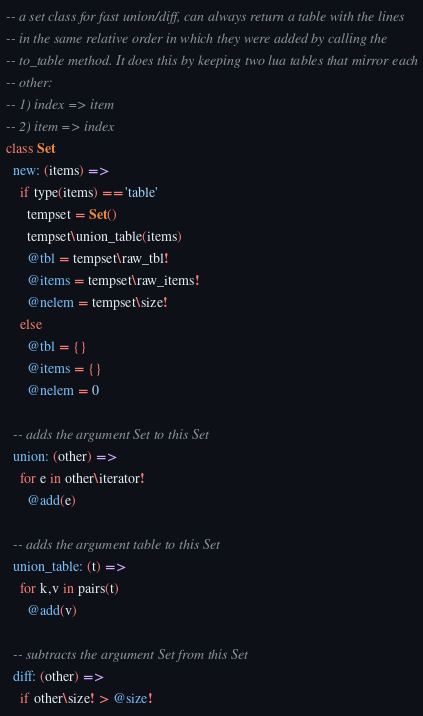Convert code to text. <code><loc_0><loc_0><loc_500><loc_500><_MoonScript_>-- a set class for fast union/diff, can always return a table with the lines
-- in the same relative order in which they were added by calling the
-- to_table method. It does this by keeping two lua tables that mirror each
-- other:
-- 1) index => item
-- 2) item => index
class Set
  new: (items) =>
    if type(items) == 'table'
      tempset = Set()
      tempset\union_table(items)
      @tbl = tempset\raw_tbl!
      @items = tempset\raw_items!
      @nelem = tempset\size!
    else
      @tbl = {}
      @items = {}
      @nelem = 0

  -- adds the argument Set to this Set
  union: (other) =>
    for e in other\iterator!
      @add(e)

  -- adds the argument table to this Set
  union_table: (t) =>
    for k,v in pairs(t)
      @add(v)

  -- subtracts the argument Set from this Set
  diff: (other) =>
    if other\size! > @size!</code> 